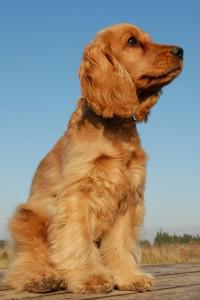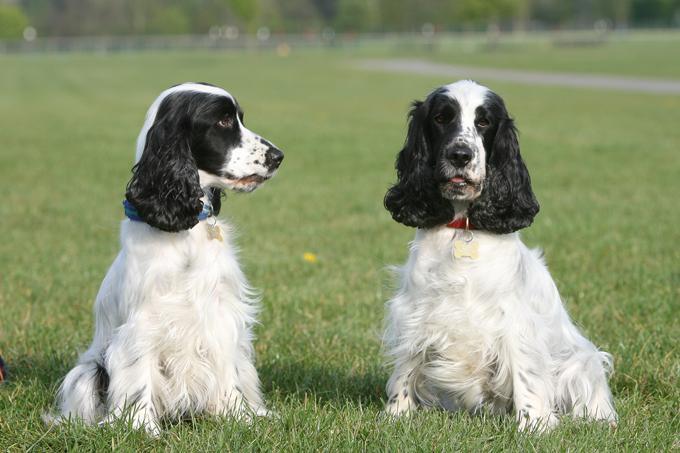The first image is the image on the left, the second image is the image on the right. Examine the images to the left and right. Is the description "There are at least four dogs." accurate? Answer yes or no. No. 